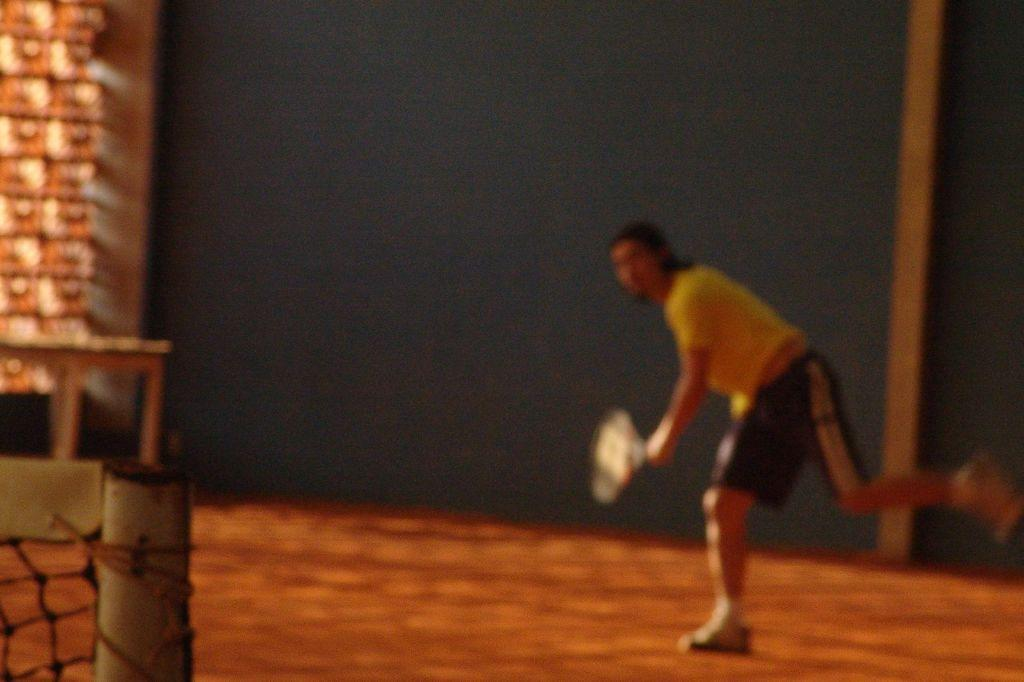Who is present in the image? There is a person in the image. What is the person holding in the image? The person is holding a shuttle bat. What can be seen on the left side of the image? There is a badminton net on the left side of the image. What color is the hole in the image? There is no hole present in the image. 